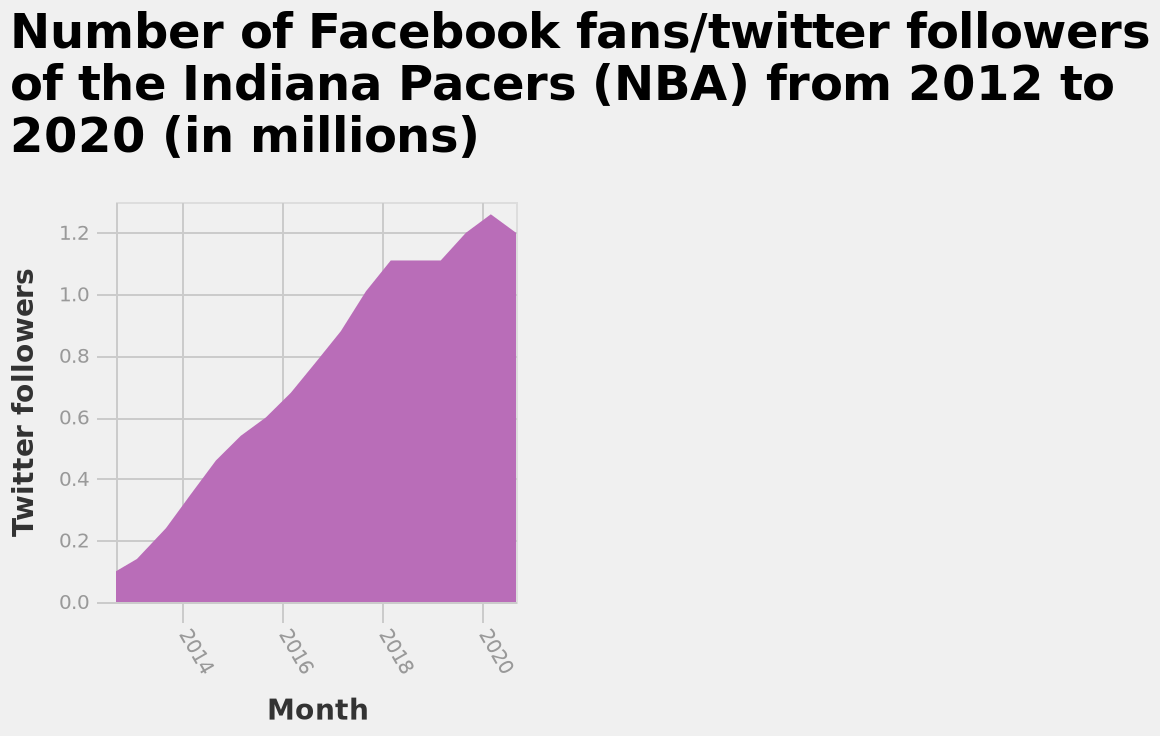<image>
What is the range of the x-axis in the area graph?  The x-axis in the area graph ranges from 2014 to 2020. 